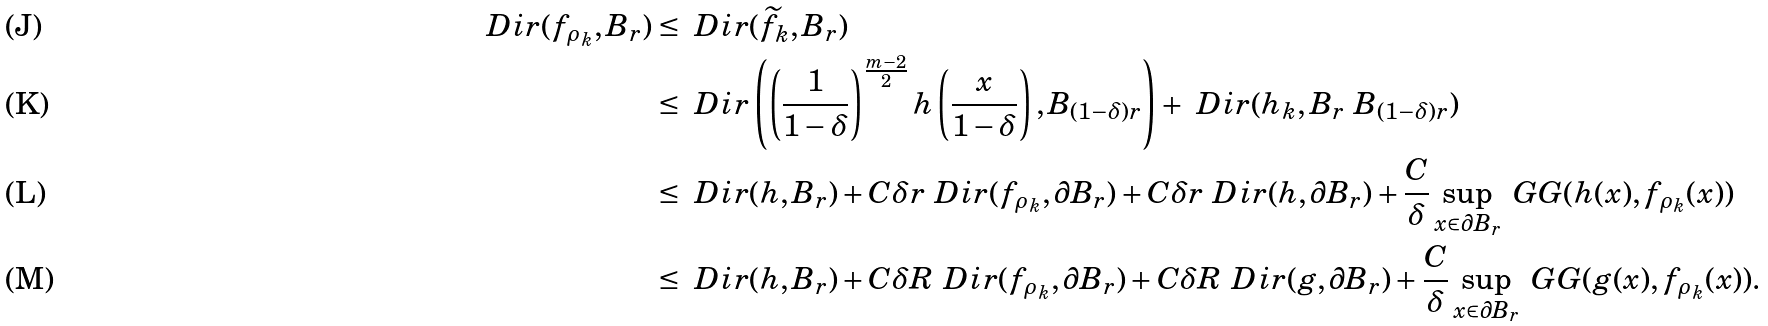Convert formula to latex. <formula><loc_0><loc_0><loc_500><loc_500>\ D i r ( f _ { \rho _ { k } } , B _ { r } ) & \leq \ D i r ( \widetilde { f } _ { k } , B _ { r } ) \\ & \leq \ D i r \left ( \left ( \frac { 1 } { 1 - \delta } \right ) ^ { \frac { m - 2 } { 2 } } h \left ( \frac { x } { 1 - \delta } \right ) , B _ { ( 1 - \delta ) r } \right ) + \ D i r ( h _ { k } , B _ { r } \ B _ { ( 1 - \delta ) r } ) \\ & \leq \ D i r ( h , B _ { r } ) + C \delta r \ D i r ( f _ { \rho _ { k } } , \partial B _ { r } ) + C \delta r \ D i r ( h , \partial B _ { r } ) + \frac { C } { \delta } \sup _ { x \in \partial B _ { r } } \ G G ( h ( x ) , f _ { \rho _ { k } } ( x ) ) \\ & \leq \ D i r ( h , B _ { r } ) + C \delta R \ D i r ( f _ { \rho _ { k } } , \partial B _ { r } ) + C \delta R \ D i r ( g , \partial B _ { r } ) + \frac { C } { \delta } \sup _ { x \in \partial B _ { r } } \ G G ( g ( x ) , f _ { \rho _ { k } } ( x ) ) .</formula> 